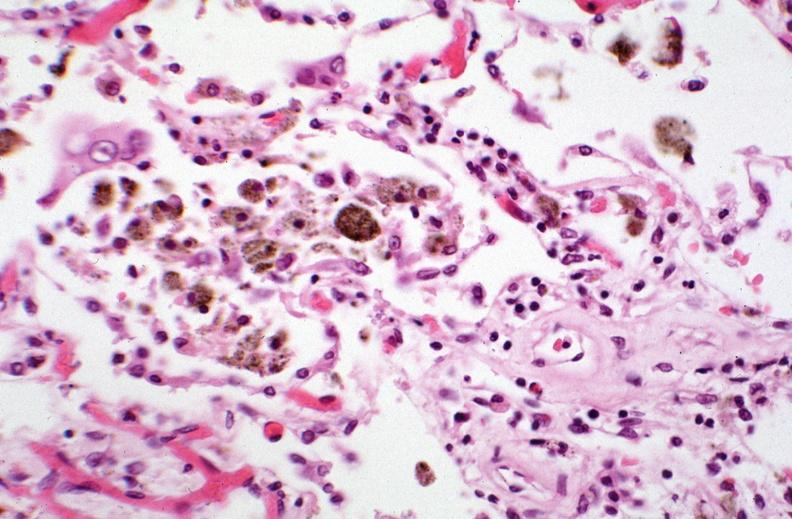where is this?
Answer the question using a single word or phrase. Lung 